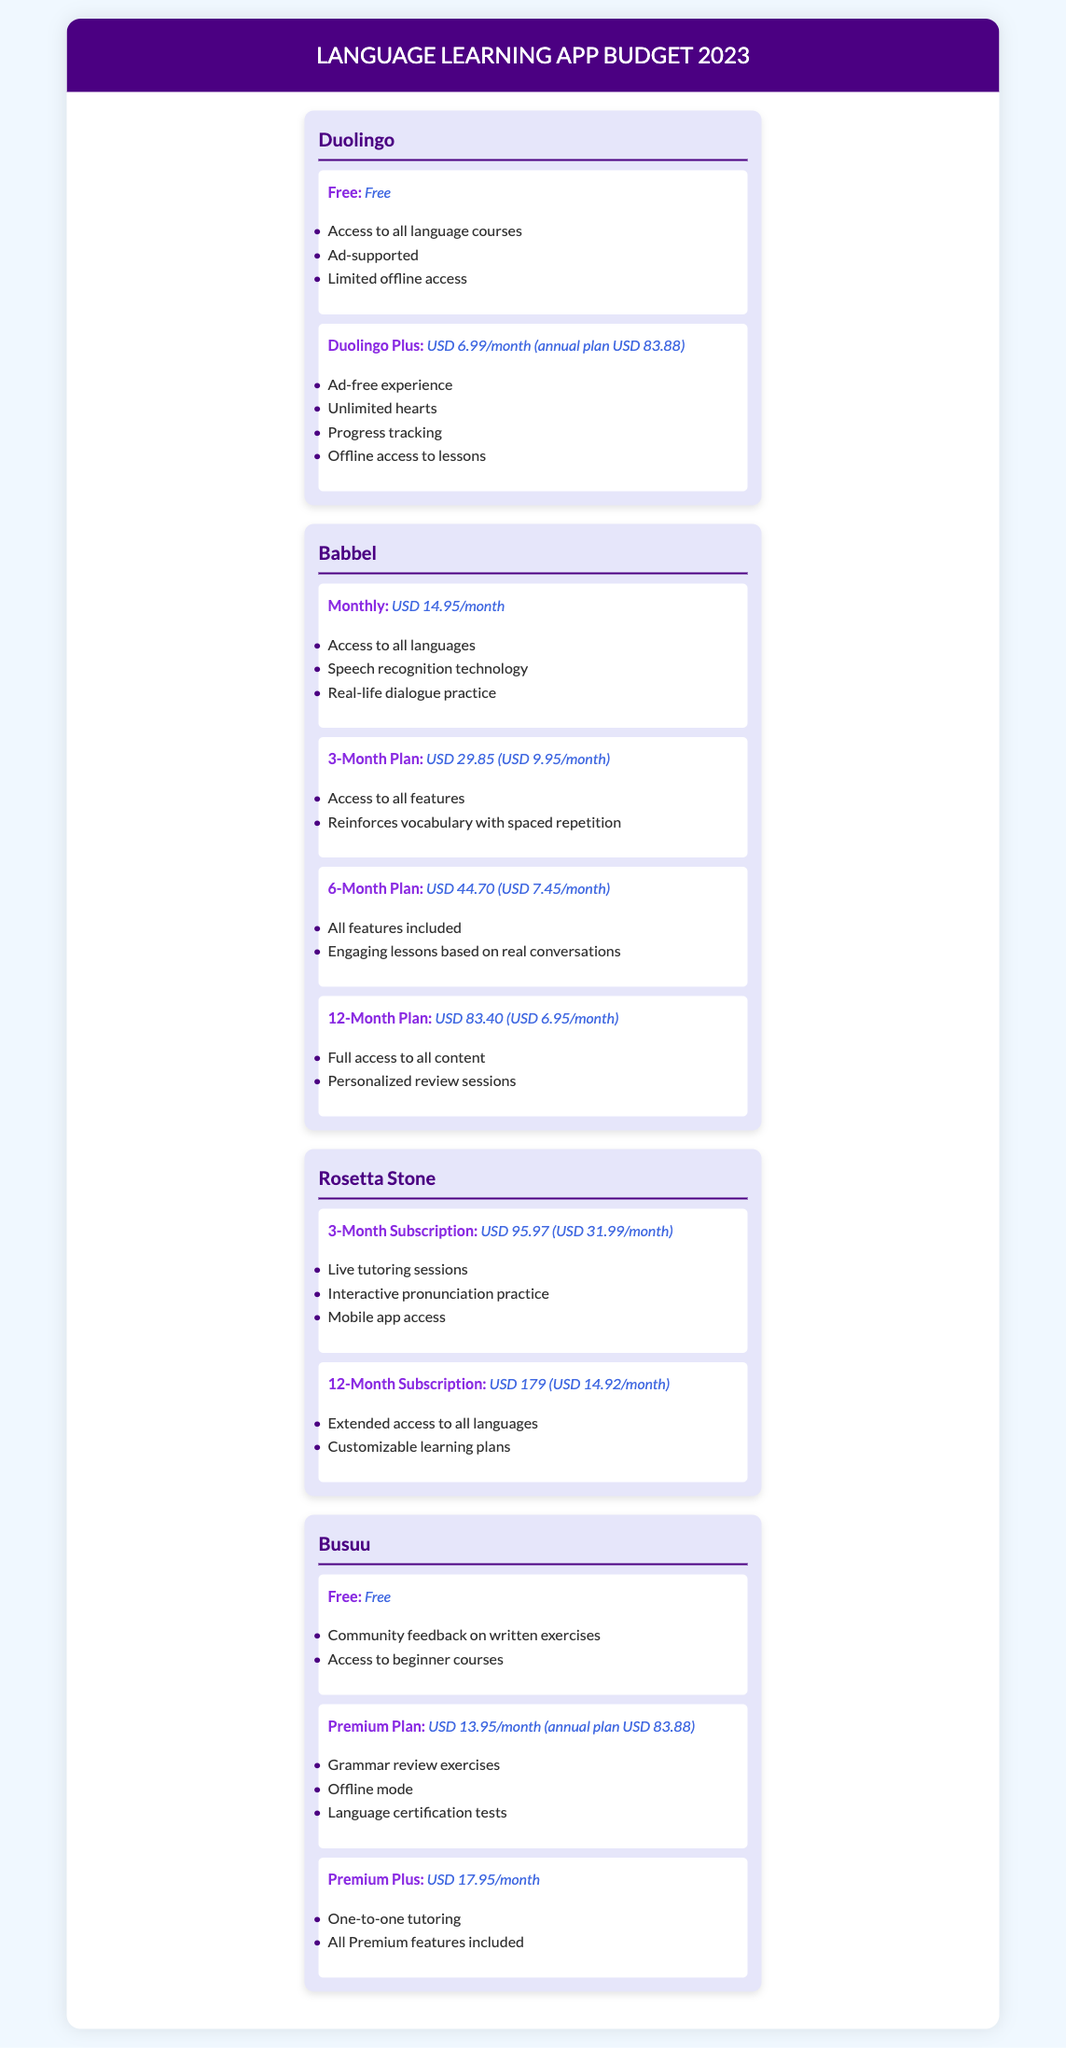What is the cost of Duolingo Plus? The cost of Duolingo Plus is specified as USD 6.99/month or USD 83.88 for an annual plan.
Answer: USD 6.99/month (annual plan USD 83.88) How many plans does Babbel offer? The document lists four plans offered by Babbel: Monthly, 3-Month Plan, 6-Month Plan, and 12-Month Plan.
Answer: Four plans What feature does the Premium Plus plan from Busuu include? The Premium Plus plan offers one-to-one tutoring as one of its features.
Answer: One-to-one tutoring What is the price of the 12-Month Subscription for Rosetta Stone? The 12-Month Subscription costs USD 179, which can be broken down to USD 14.92/month.
Answer: USD 179 (USD 14.92/month) Which app offers a free subscription with community feedback? Busuu offers a free subscription that includes community feedback on written exercises.
Answer: Busuu What unique technology does Babbel use? Babbel utilizes speech recognition technology as part of its features.
Answer: Speech recognition technology What is the annual cost of the Duolingo Plus subscription? The annual cost for Duolingo Plus is mentioned as USD 83.88.
Answer: USD 83.88 Which plan is the most affordable monthly option for Babbel? The 12-Month Plan is the most affordable monthly option at USD 6.95/month when averaged out.
Answer: USD 6.95/month 